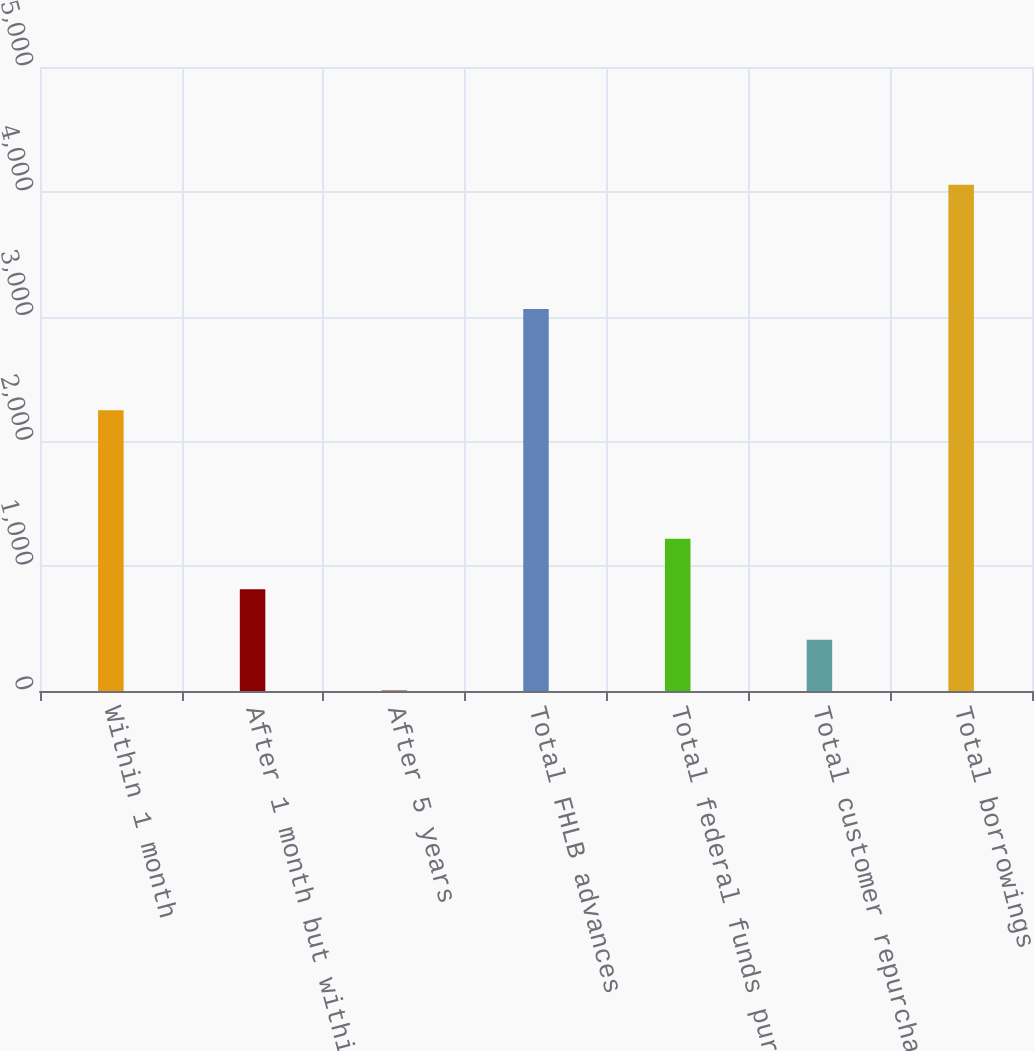Convert chart to OTSL. <chart><loc_0><loc_0><loc_500><loc_500><bar_chart><fcel>Within 1 month<fcel>After 1 month but within 1<fcel>After 5 years<fcel>Total FHLB advances<fcel>Total federal funds purchased<fcel>Total customer repurchase<fcel>Total borrowings<nl><fcel>2250<fcel>815.36<fcel>5<fcel>3061.1<fcel>1220.54<fcel>410.18<fcel>4056.8<nl></chart> 